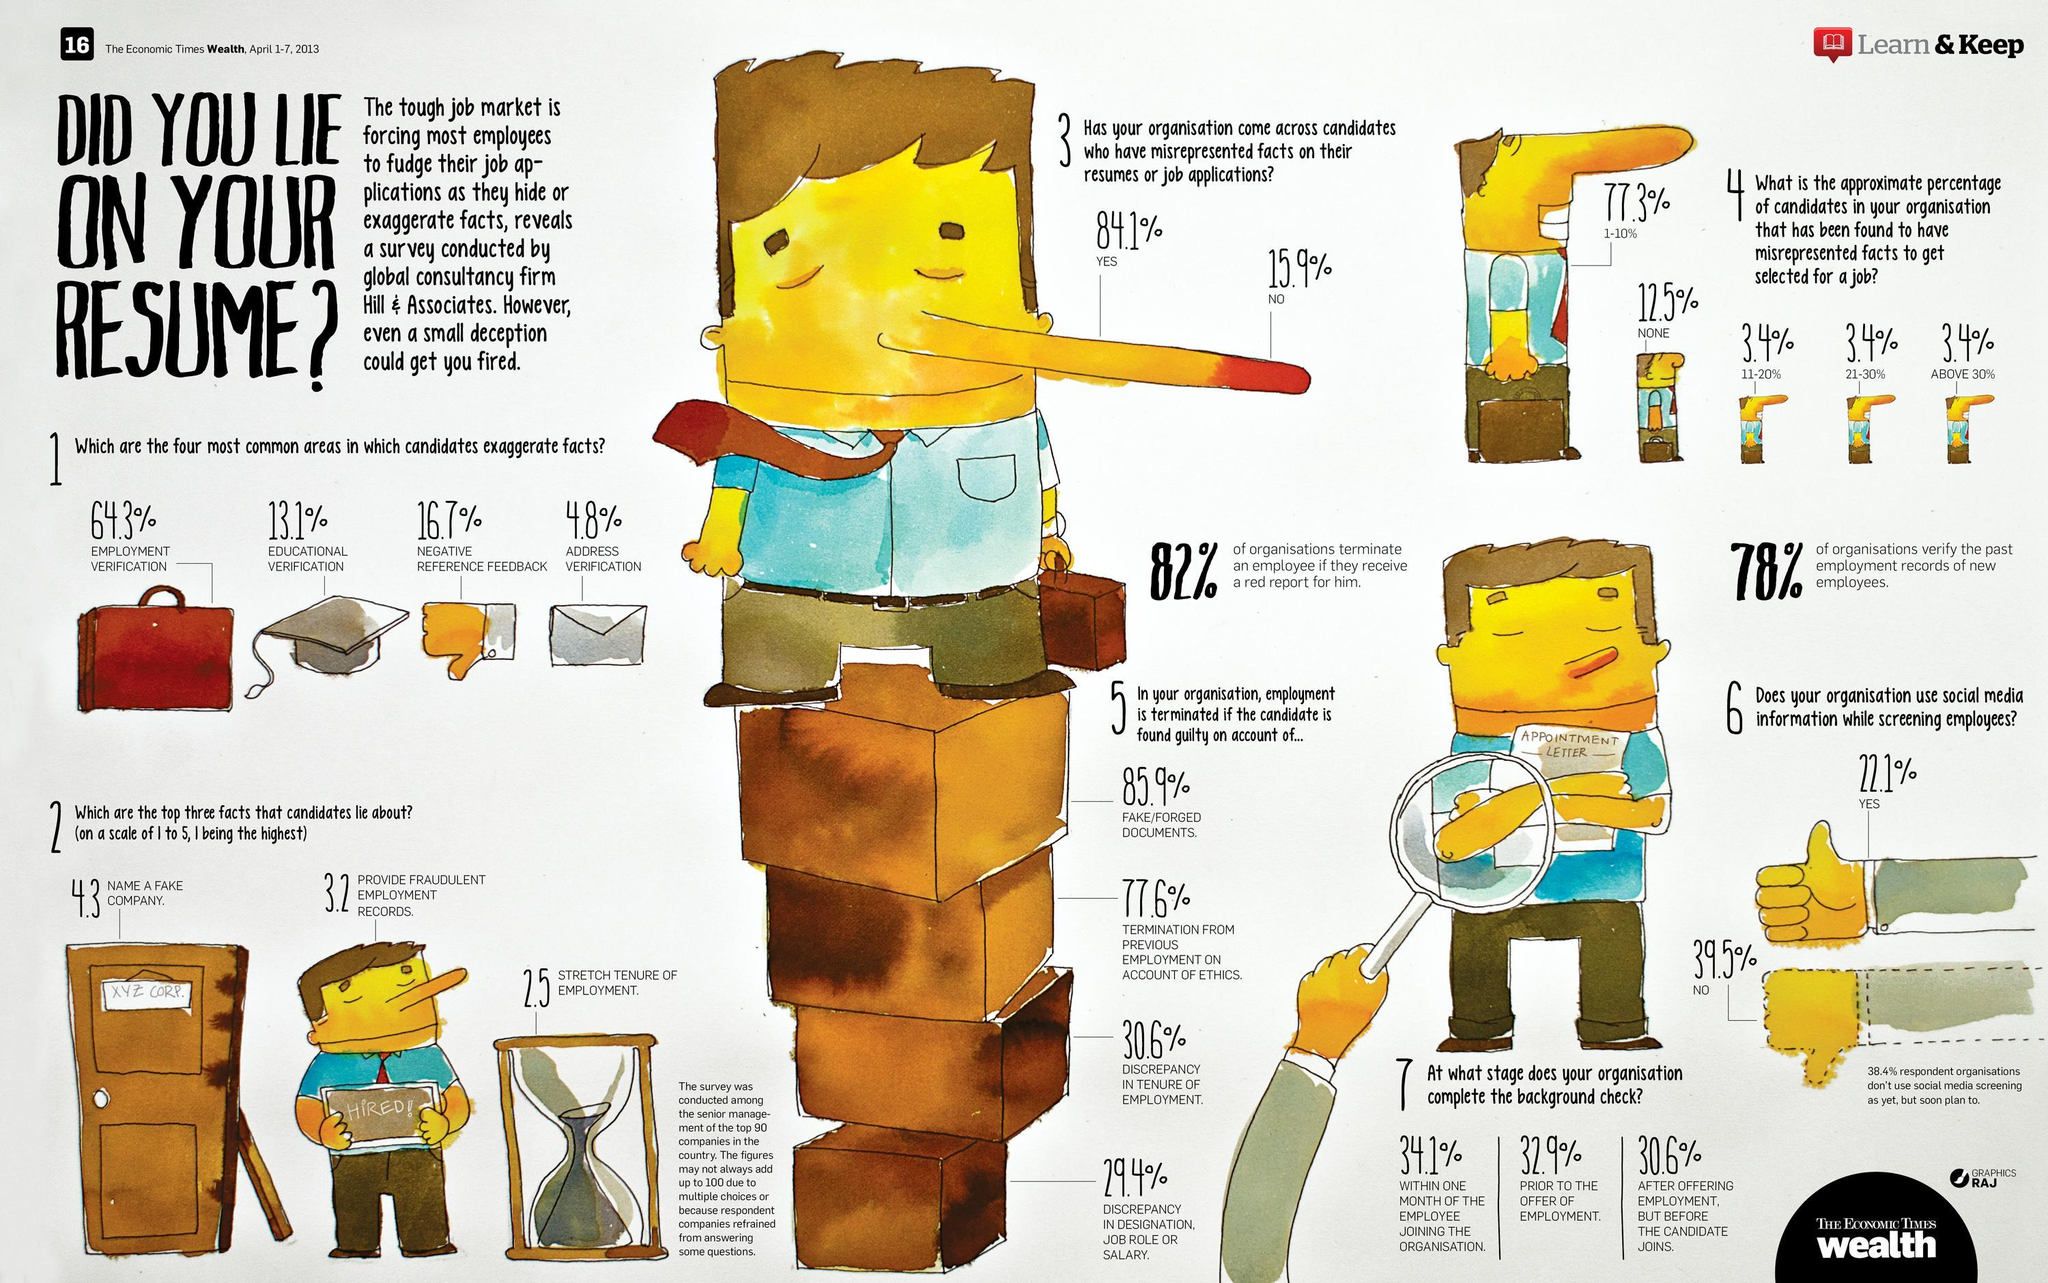What is the sum of all organisations who do not or who plan to use social media while screening employees
Answer the question with a short phrase. 77.9 what is the name written on the door? XYZ CORP what is the third reason why employment is terminated Discrepancy in tenure of employment which area are the facts least exaggerated? educational verification what is the percentage of candidates who have not misrepresented facts 12.5 